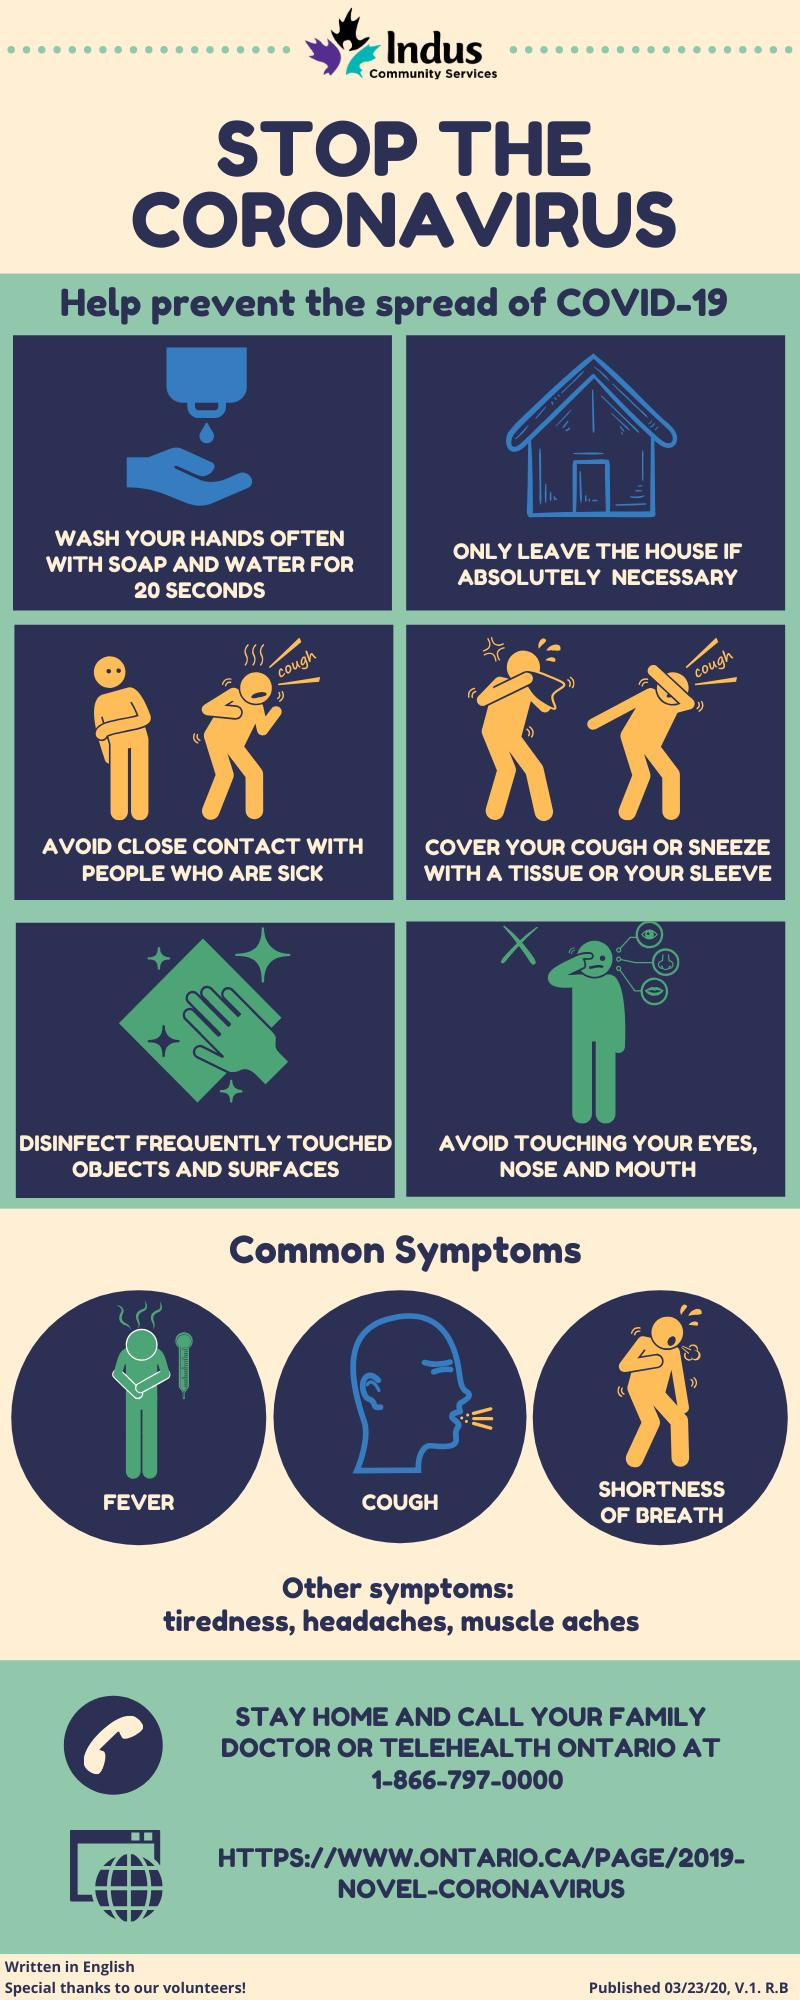Indicate a few pertinent items in this graphic. The third common symptom mentioned is shortness of breath. It is imperative to disinfect frequently touched objects and surfaces in order to prevent the spread of COVID-19, as specified in the fifth step mentioned. To prevent the spread of COVID-19, individuals should only leave their homes if it is absolutely necessary and refrain from social distancing measures. The sixth recommended step to prevent the spread of COVID-19 is to avoid touching the eyes, nose, and mouth. According to the minimum duration for hand washing as mentioned, it is required to wash your hands for at least 20 seconds. 